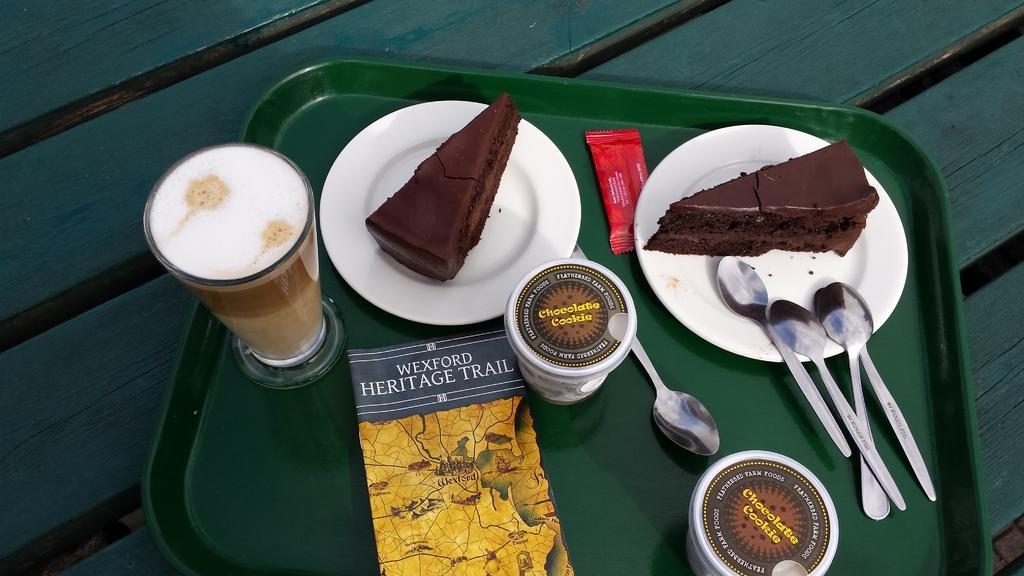Can you describe this image briefly? In this image these are spoons, cups, glass of coffee, book,a packet, two cake slices on the plates ,on the tray, on the wooden board. 